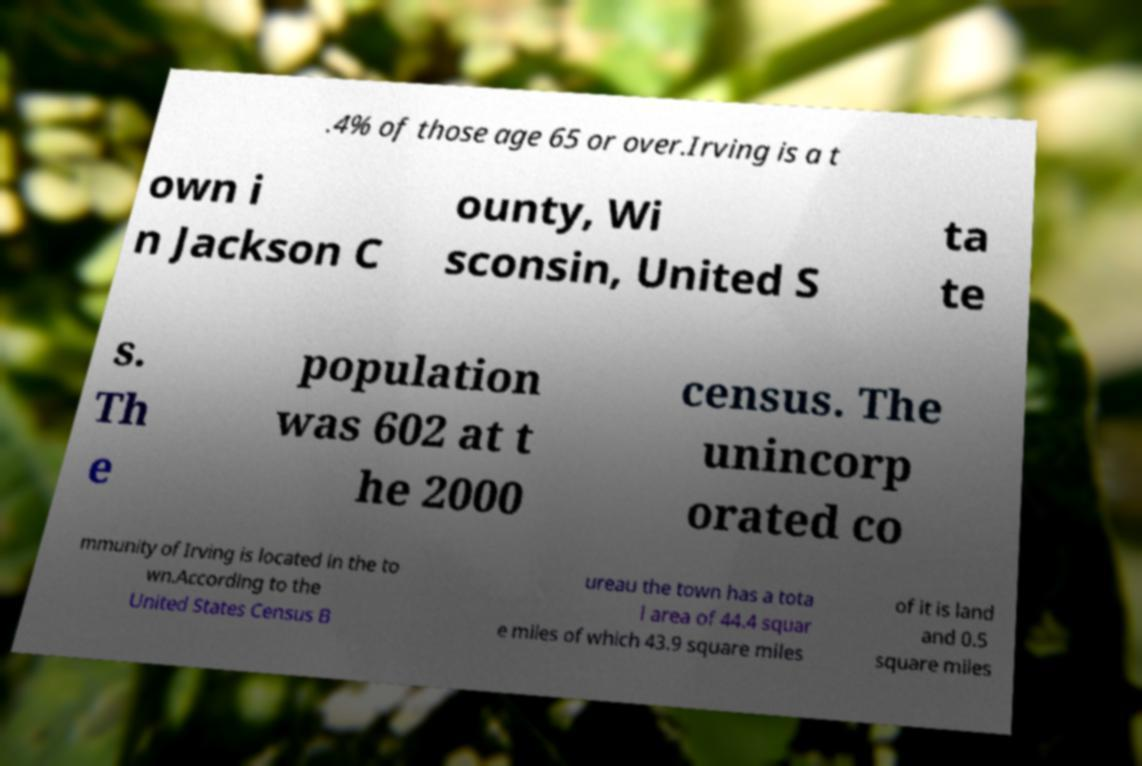There's text embedded in this image that I need extracted. Can you transcribe it verbatim? .4% of those age 65 or over.Irving is a t own i n Jackson C ounty, Wi sconsin, United S ta te s. Th e population was 602 at t he 2000 census. The unincorp orated co mmunity of Irving is located in the to wn.According to the United States Census B ureau the town has a tota l area of 44.4 squar e miles of which 43.9 square miles of it is land and 0.5 square miles 